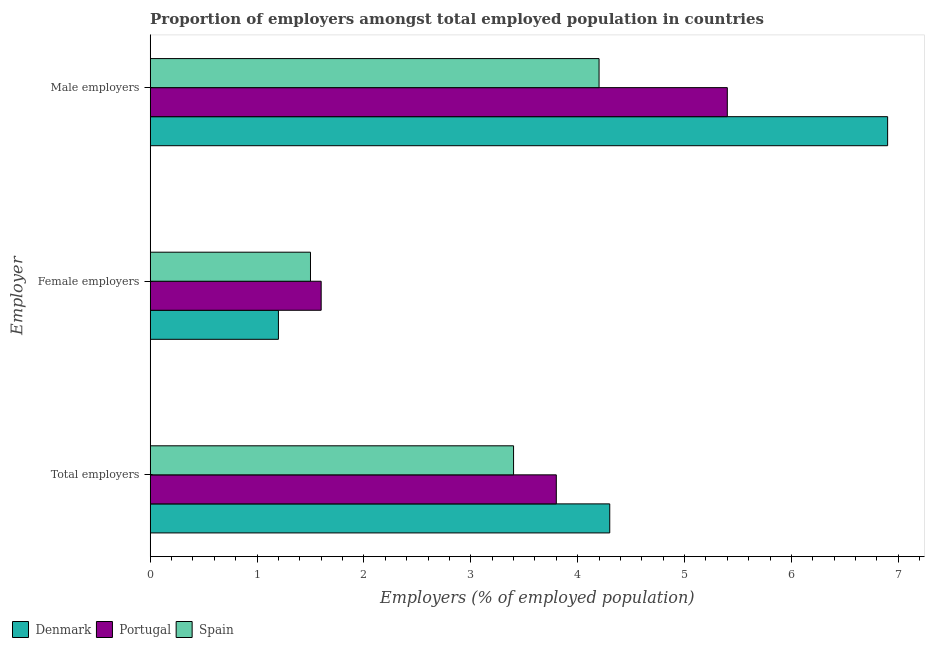How many different coloured bars are there?
Keep it short and to the point. 3. How many groups of bars are there?
Your answer should be very brief. 3. Are the number of bars per tick equal to the number of legend labels?
Your answer should be compact. Yes. Are the number of bars on each tick of the Y-axis equal?
Make the answer very short. Yes. How many bars are there on the 3rd tick from the bottom?
Ensure brevity in your answer.  3. What is the label of the 2nd group of bars from the top?
Your answer should be compact. Female employers. Across all countries, what is the maximum percentage of female employers?
Make the answer very short. 1.6. Across all countries, what is the minimum percentage of female employers?
Provide a short and direct response. 1.2. In which country was the percentage of female employers maximum?
Give a very brief answer. Portugal. In which country was the percentage of female employers minimum?
Offer a very short reply. Denmark. What is the total percentage of female employers in the graph?
Your response must be concise. 4.3. What is the difference between the percentage of male employers in Spain and that in Denmark?
Your answer should be compact. -2.7. What is the difference between the percentage of male employers in Spain and the percentage of female employers in Portugal?
Offer a very short reply. 2.6. What is the average percentage of total employers per country?
Keep it short and to the point. 3.83. What is the difference between the percentage of female employers and percentage of male employers in Portugal?
Provide a succinct answer. -3.8. In how many countries, is the percentage of female employers greater than 6.6 %?
Provide a succinct answer. 0. What is the ratio of the percentage of female employers in Spain to that in Denmark?
Your answer should be very brief. 1.25. What is the difference between the highest and the second highest percentage of female employers?
Provide a short and direct response. 0.1. What is the difference between the highest and the lowest percentage of total employers?
Provide a succinct answer. 0.9. In how many countries, is the percentage of male employers greater than the average percentage of male employers taken over all countries?
Offer a very short reply. 1. What does the 2nd bar from the bottom in Female employers represents?
Offer a very short reply. Portugal. Is it the case that in every country, the sum of the percentage of total employers and percentage of female employers is greater than the percentage of male employers?
Make the answer very short. No. Does the graph contain grids?
Ensure brevity in your answer.  No. How many legend labels are there?
Provide a succinct answer. 3. What is the title of the graph?
Your response must be concise. Proportion of employers amongst total employed population in countries. What is the label or title of the X-axis?
Ensure brevity in your answer.  Employers (% of employed population). What is the label or title of the Y-axis?
Give a very brief answer. Employer. What is the Employers (% of employed population) in Denmark in Total employers?
Your answer should be compact. 4.3. What is the Employers (% of employed population) in Portugal in Total employers?
Make the answer very short. 3.8. What is the Employers (% of employed population) of Spain in Total employers?
Ensure brevity in your answer.  3.4. What is the Employers (% of employed population) of Denmark in Female employers?
Make the answer very short. 1.2. What is the Employers (% of employed population) of Portugal in Female employers?
Give a very brief answer. 1.6. What is the Employers (% of employed population) in Denmark in Male employers?
Give a very brief answer. 6.9. What is the Employers (% of employed population) of Portugal in Male employers?
Offer a terse response. 5.4. What is the Employers (% of employed population) in Spain in Male employers?
Give a very brief answer. 4.2. Across all Employer, what is the maximum Employers (% of employed population) in Denmark?
Offer a terse response. 6.9. Across all Employer, what is the maximum Employers (% of employed population) in Portugal?
Keep it short and to the point. 5.4. Across all Employer, what is the maximum Employers (% of employed population) in Spain?
Your response must be concise. 4.2. Across all Employer, what is the minimum Employers (% of employed population) of Denmark?
Give a very brief answer. 1.2. Across all Employer, what is the minimum Employers (% of employed population) in Portugal?
Make the answer very short. 1.6. What is the total Employers (% of employed population) in Portugal in the graph?
Offer a terse response. 10.8. What is the total Employers (% of employed population) of Spain in the graph?
Ensure brevity in your answer.  9.1. What is the difference between the Employers (% of employed population) of Denmark in Total employers and that in Female employers?
Provide a succinct answer. 3.1. What is the difference between the Employers (% of employed population) in Denmark in Total employers and that in Male employers?
Keep it short and to the point. -2.6. What is the difference between the Employers (% of employed population) in Spain in Total employers and that in Male employers?
Your answer should be compact. -0.8. What is the difference between the Employers (% of employed population) in Portugal in Female employers and that in Male employers?
Keep it short and to the point. -3.8. What is the difference between the Employers (% of employed population) in Denmark in Total employers and the Employers (% of employed population) in Portugal in Female employers?
Offer a very short reply. 2.7. What is the difference between the Employers (% of employed population) in Denmark in Total employers and the Employers (% of employed population) in Spain in Female employers?
Give a very brief answer. 2.8. What is the difference between the Employers (% of employed population) of Denmark in Total employers and the Employers (% of employed population) of Portugal in Male employers?
Ensure brevity in your answer.  -1.1. What is the difference between the Employers (% of employed population) of Portugal in Total employers and the Employers (% of employed population) of Spain in Male employers?
Ensure brevity in your answer.  -0.4. What is the difference between the Employers (% of employed population) in Denmark in Female employers and the Employers (% of employed population) in Portugal in Male employers?
Offer a very short reply. -4.2. What is the difference between the Employers (% of employed population) in Denmark in Female employers and the Employers (% of employed population) in Spain in Male employers?
Your answer should be compact. -3. What is the average Employers (% of employed population) in Denmark per Employer?
Your answer should be compact. 4.13. What is the average Employers (% of employed population) in Portugal per Employer?
Provide a succinct answer. 3.6. What is the average Employers (% of employed population) in Spain per Employer?
Your answer should be very brief. 3.03. What is the difference between the Employers (% of employed population) in Denmark and Employers (% of employed population) in Portugal in Total employers?
Make the answer very short. 0.5. What is the difference between the Employers (% of employed population) in Portugal and Employers (% of employed population) in Spain in Male employers?
Make the answer very short. 1.2. What is the ratio of the Employers (% of employed population) in Denmark in Total employers to that in Female employers?
Make the answer very short. 3.58. What is the ratio of the Employers (% of employed population) of Portugal in Total employers to that in Female employers?
Provide a succinct answer. 2.38. What is the ratio of the Employers (% of employed population) of Spain in Total employers to that in Female employers?
Offer a terse response. 2.27. What is the ratio of the Employers (% of employed population) of Denmark in Total employers to that in Male employers?
Give a very brief answer. 0.62. What is the ratio of the Employers (% of employed population) of Portugal in Total employers to that in Male employers?
Ensure brevity in your answer.  0.7. What is the ratio of the Employers (% of employed population) of Spain in Total employers to that in Male employers?
Your answer should be compact. 0.81. What is the ratio of the Employers (% of employed population) in Denmark in Female employers to that in Male employers?
Keep it short and to the point. 0.17. What is the ratio of the Employers (% of employed population) of Portugal in Female employers to that in Male employers?
Provide a succinct answer. 0.3. What is the ratio of the Employers (% of employed population) of Spain in Female employers to that in Male employers?
Your answer should be compact. 0.36. What is the difference between the highest and the second highest Employers (% of employed population) in Spain?
Give a very brief answer. 0.8. What is the difference between the highest and the lowest Employers (% of employed population) in Denmark?
Ensure brevity in your answer.  5.7. What is the difference between the highest and the lowest Employers (% of employed population) in Portugal?
Keep it short and to the point. 3.8. 